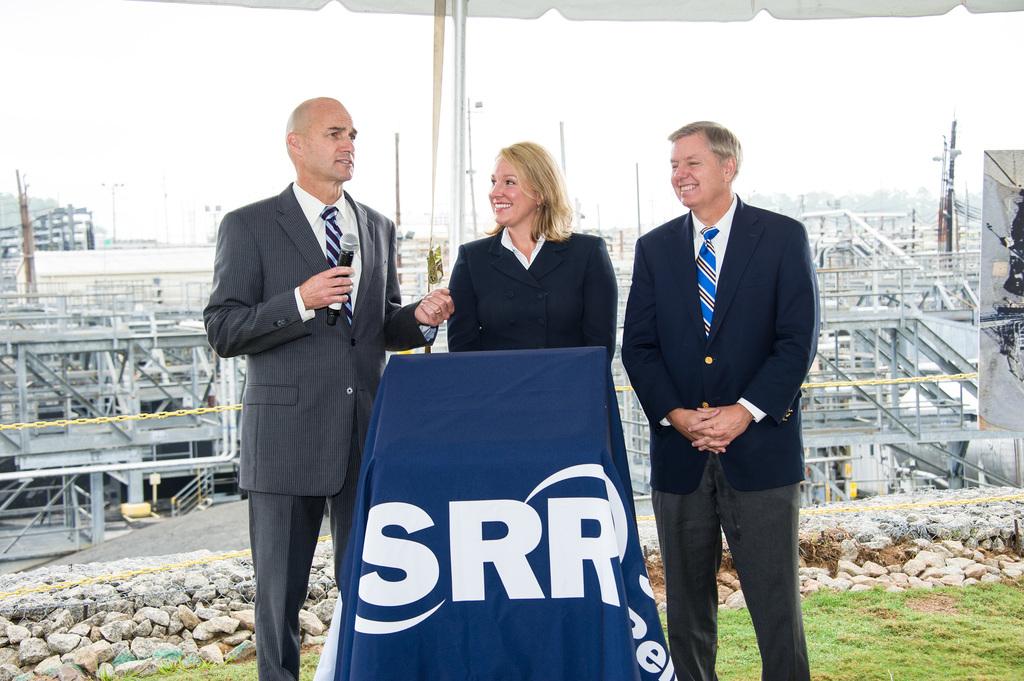What color are the letters srr on the cloth?
Ensure brevity in your answer.  White. 